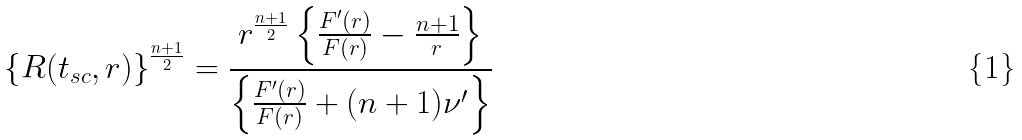Convert formula to latex. <formula><loc_0><loc_0><loc_500><loc_500>\left \{ R ( t _ { s c } , r ) \right \} ^ { \frac { n + 1 } { 2 } } = \frac { r ^ { \frac { n + 1 } { 2 } } \left \{ \frac { F ^ { \prime } ( r ) } { F ( r ) } - \frac { n + 1 } { r } \right \} } { \left \{ \frac { F ^ { \prime } ( r ) } { F ( r ) } + ( n + 1 ) \nu ^ { \prime } \right \} }</formula> 